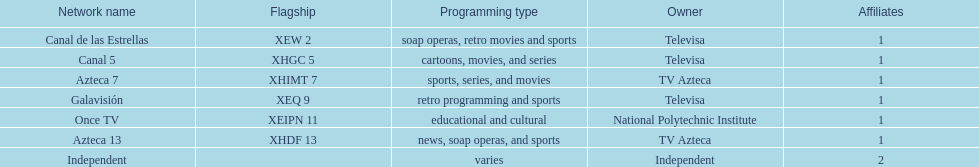Who is the only network owner listed in a consecutive order in the chart? Televisa. 